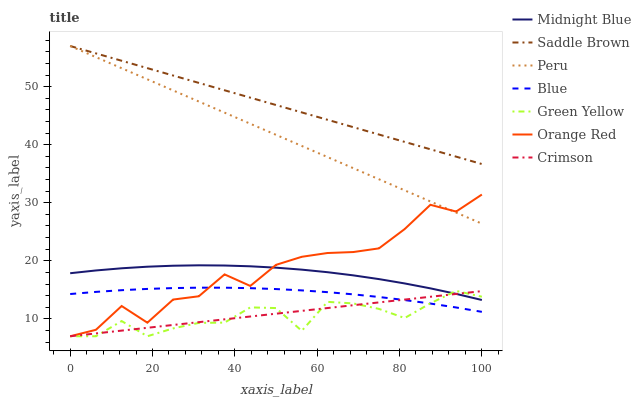Does Green Yellow have the minimum area under the curve?
Answer yes or no. Yes. Does Saddle Brown have the maximum area under the curve?
Answer yes or no. Yes. Does Midnight Blue have the minimum area under the curve?
Answer yes or no. No. Does Midnight Blue have the maximum area under the curve?
Answer yes or no. No. Is Crimson the smoothest?
Answer yes or no. Yes. Is Orange Red the roughest?
Answer yes or no. Yes. Is Midnight Blue the smoothest?
Answer yes or no. No. Is Midnight Blue the roughest?
Answer yes or no. No. Does Midnight Blue have the lowest value?
Answer yes or no. No. Does Peru have the highest value?
Answer yes or no. Yes. Does Midnight Blue have the highest value?
Answer yes or no. No. Is Blue less than Peru?
Answer yes or no. Yes. Is Midnight Blue greater than Blue?
Answer yes or no. Yes. Does Crimson intersect Midnight Blue?
Answer yes or no. Yes. Is Crimson less than Midnight Blue?
Answer yes or no. No. Is Crimson greater than Midnight Blue?
Answer yes or no. No. Does Blue intersect Peru?
Answer yes or no. No. 